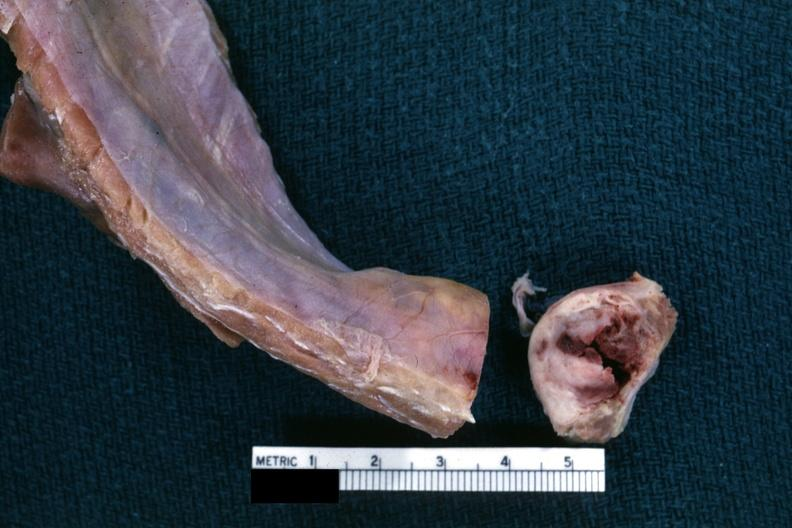s hours present?
Answer the question using a single word or phrase. No 